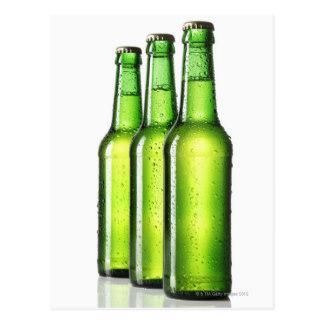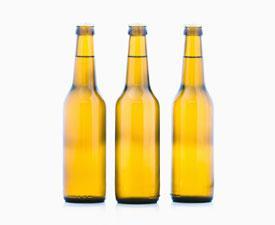The first image is the image on the left, the second image is the image on the right. Considering the images on both sides, is "All beer bottles are standing upright." valid? Answer yes or no. Yes. The first image is the image on the left, the second image is the image on the right. Considering the images on both sides, is "There are three green glass bottles" valid? Answer yes or no. Yes. 